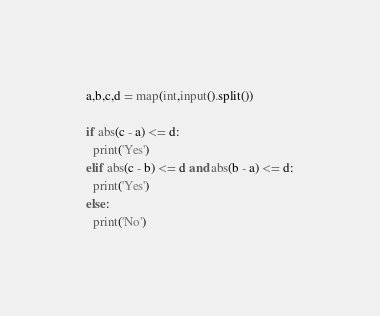<code> <loc_0><loc_0><loc_500><loc_500><_Python_>a,b,c,d = map(int,input().split())

if abs(c - a) <= d:
  print('Yes')
elif abs(c - b) <= d and abs(b - a) <= d:
  print('Yes')
else:
  print('No')</code> 